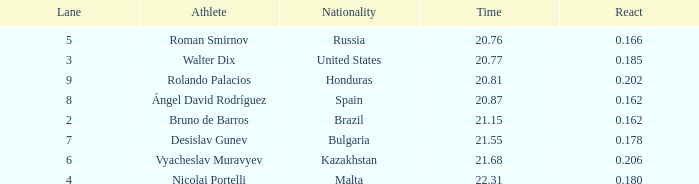What's Russia's lane when they were ranked before 1? None. 